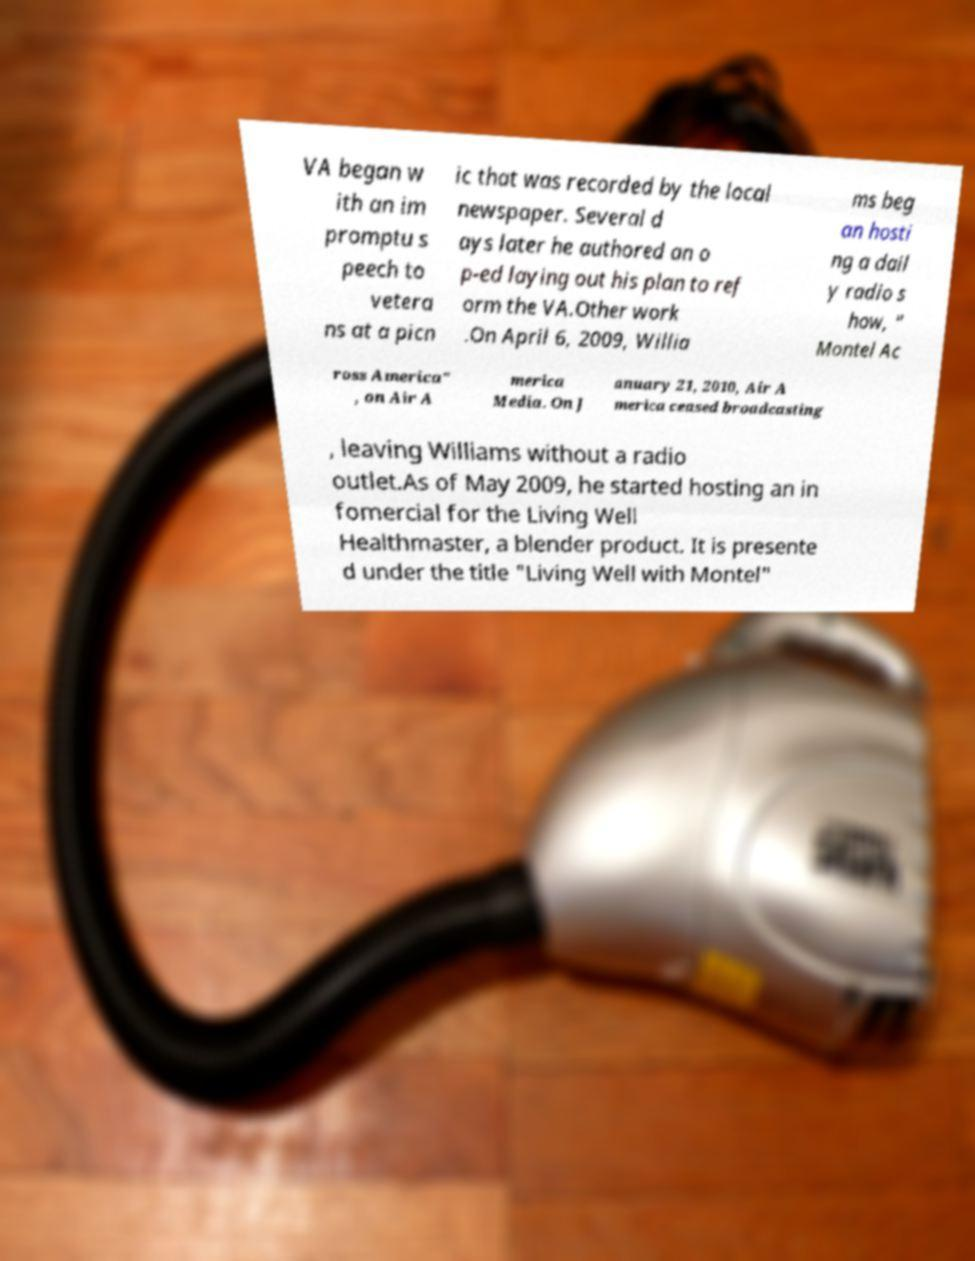I need the written content from this picture converted into text. Can you do that? VA began w ith an im promptu s peech to vetera ns at a picn ic that was recorded by the local newspaper. Several d ays later he authored an o p-ed laying out his plan to ref orm the VA.Other work .On April 6, 2009, Willia ms beg an hosti ng a dail y radio s how, " Montel Ac ross America" , on Air A merica Media. On J anuary 21, 2010, Air A merica ceased broadcasting , leaving Williams without a radio outlet.As of May 2009, he started hosting an in fomercial for the Living Well Healthmaster, a blender product. It is presente d under the title "Living Well with Montel" 